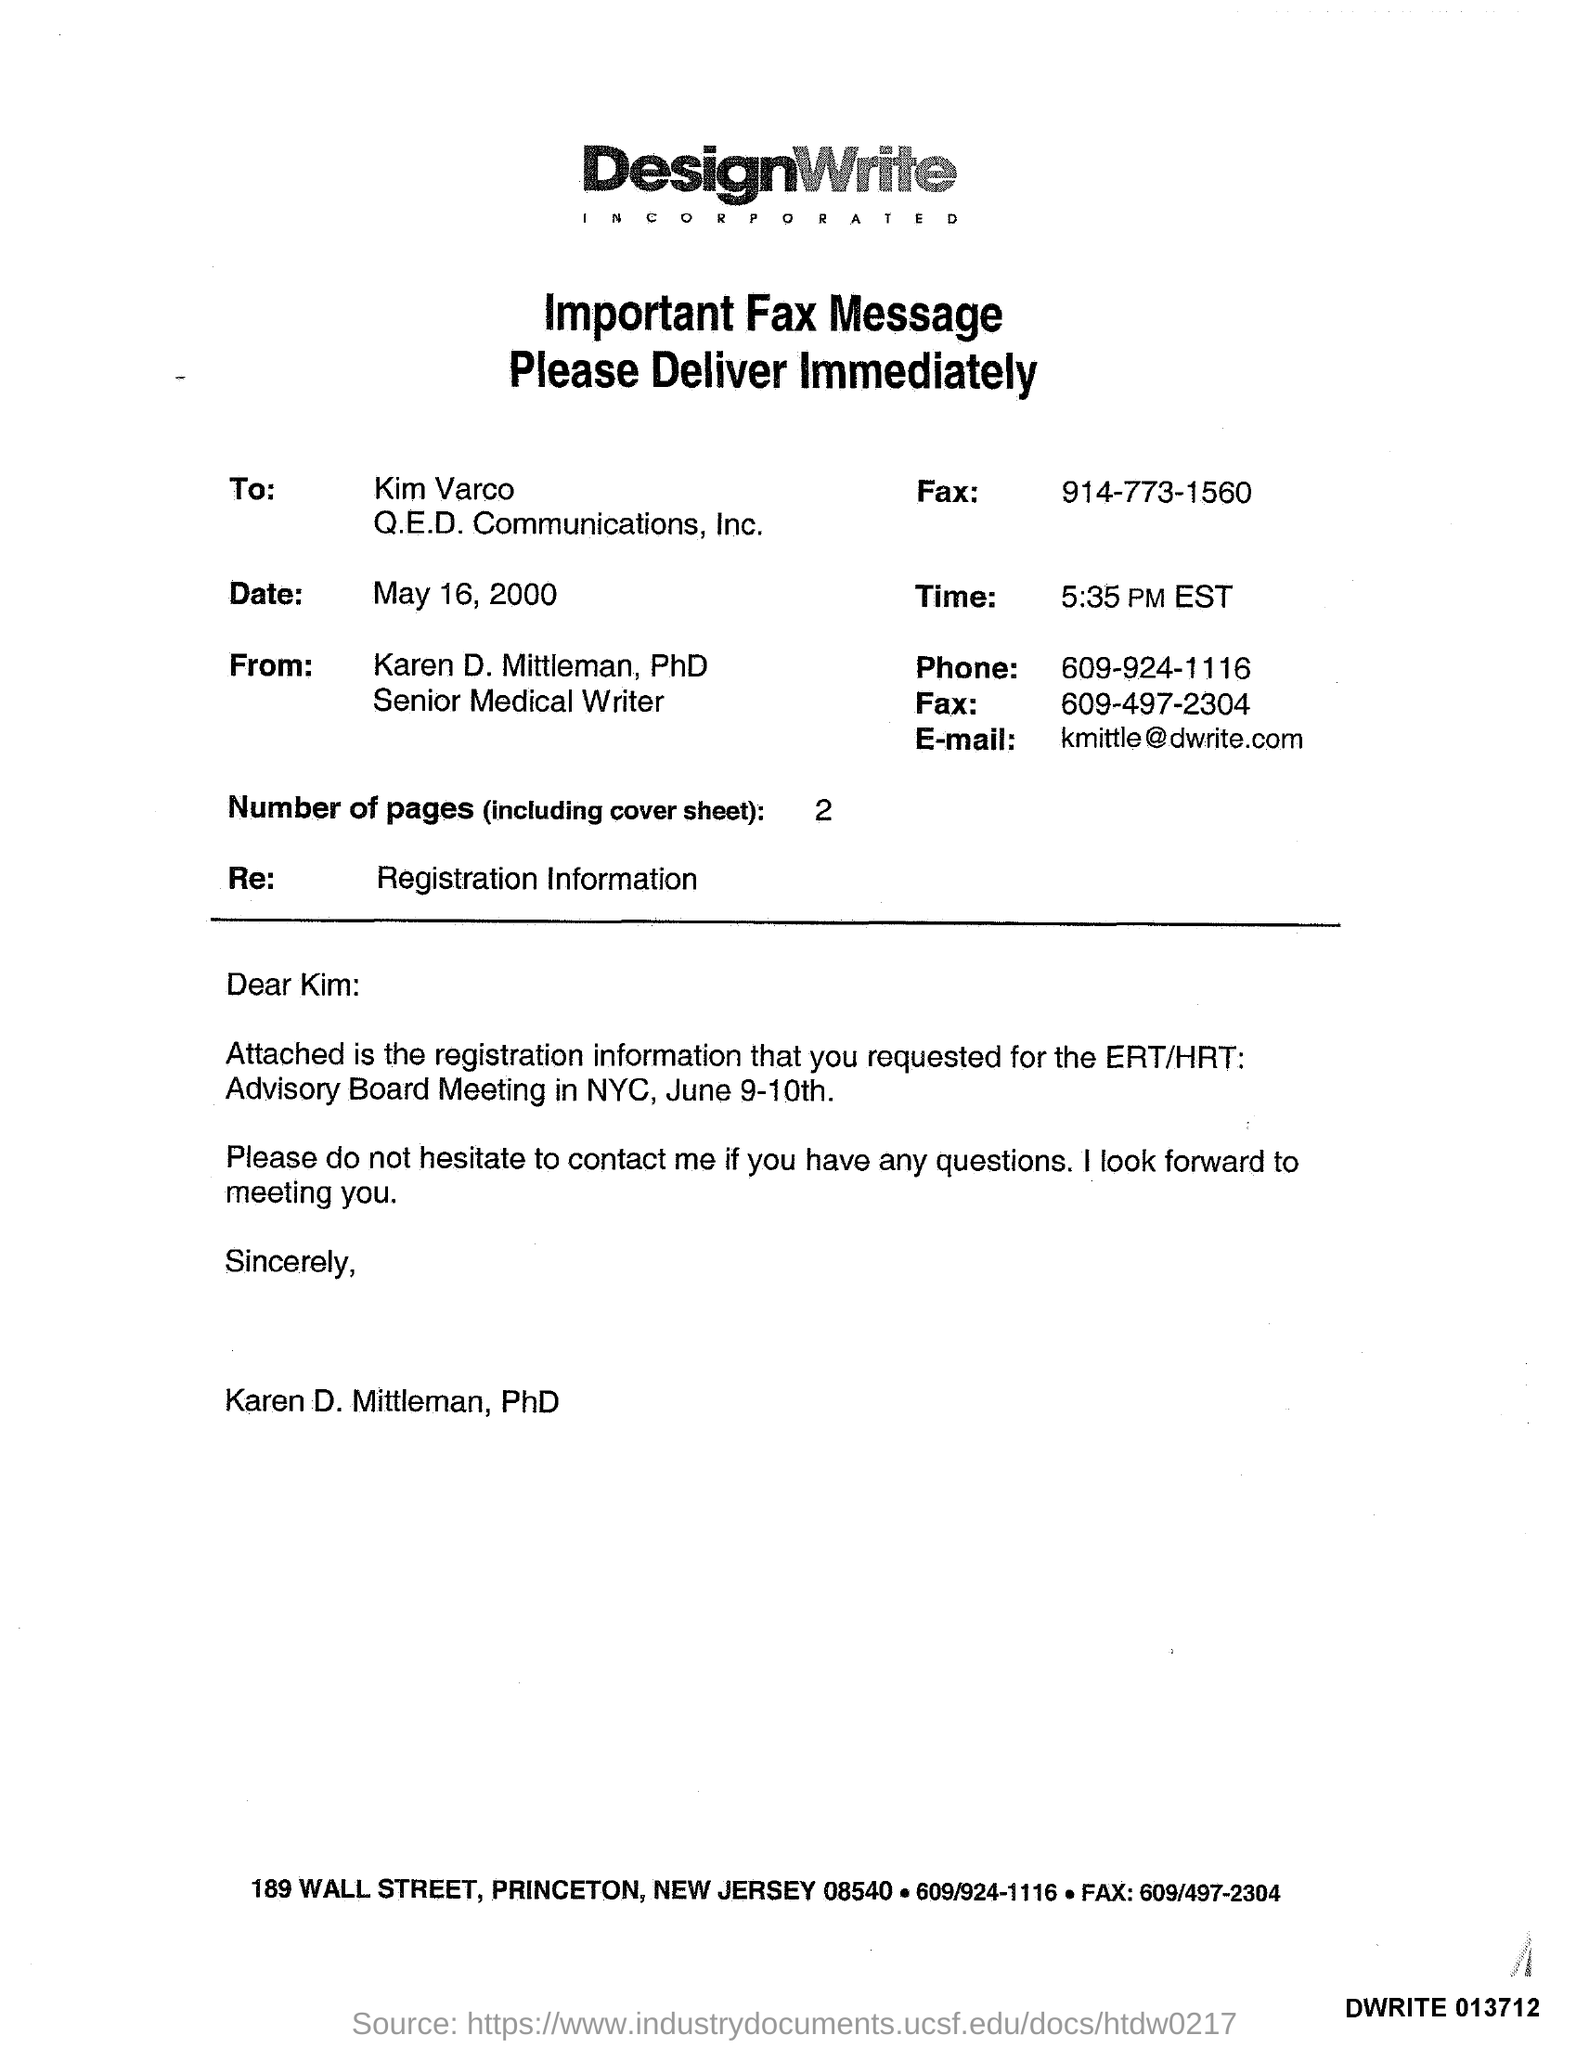List a handful of essential elements in this visual. The email mentioned in the given fax message is [kmittle@dwrite.com](mailto:kmittle@dwrite.com). The registration information mentioned in the given fax message refers to "registration. This fax message was delivered to whom? Karen D. Mittleman, PhD, Senior Medical Writer. The date mentioned in the fax message is May 16, 2000. The time mentioned in the given fax message is 5:35 pm EST. 